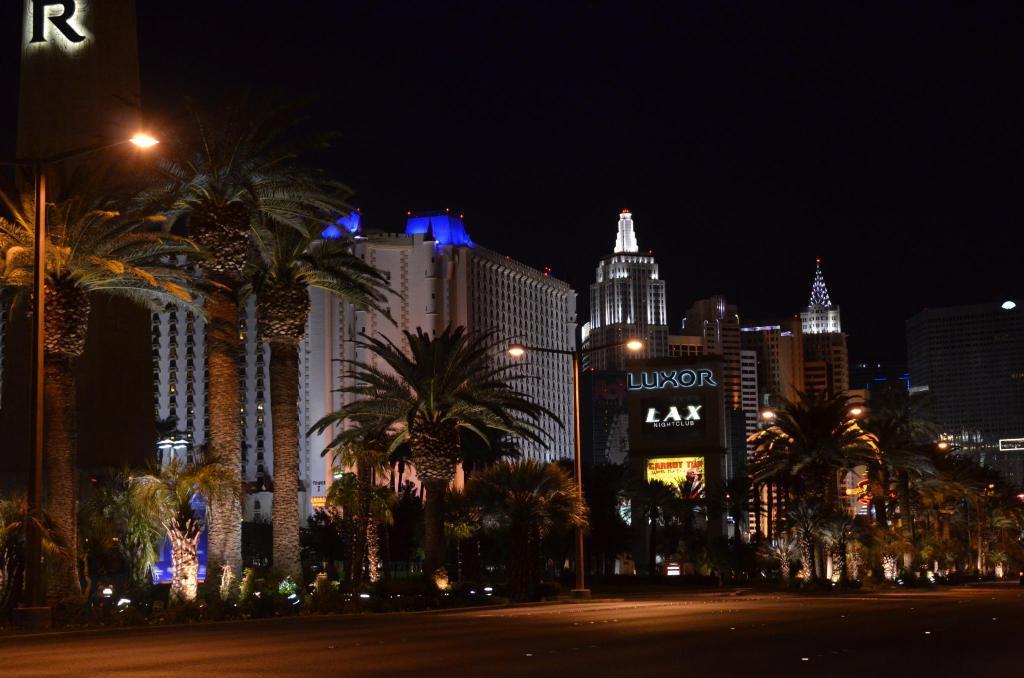Could you give a brief overview of what you see in this image? In this picture I can see buildings, poles, lights, trees, and there is dark background. 